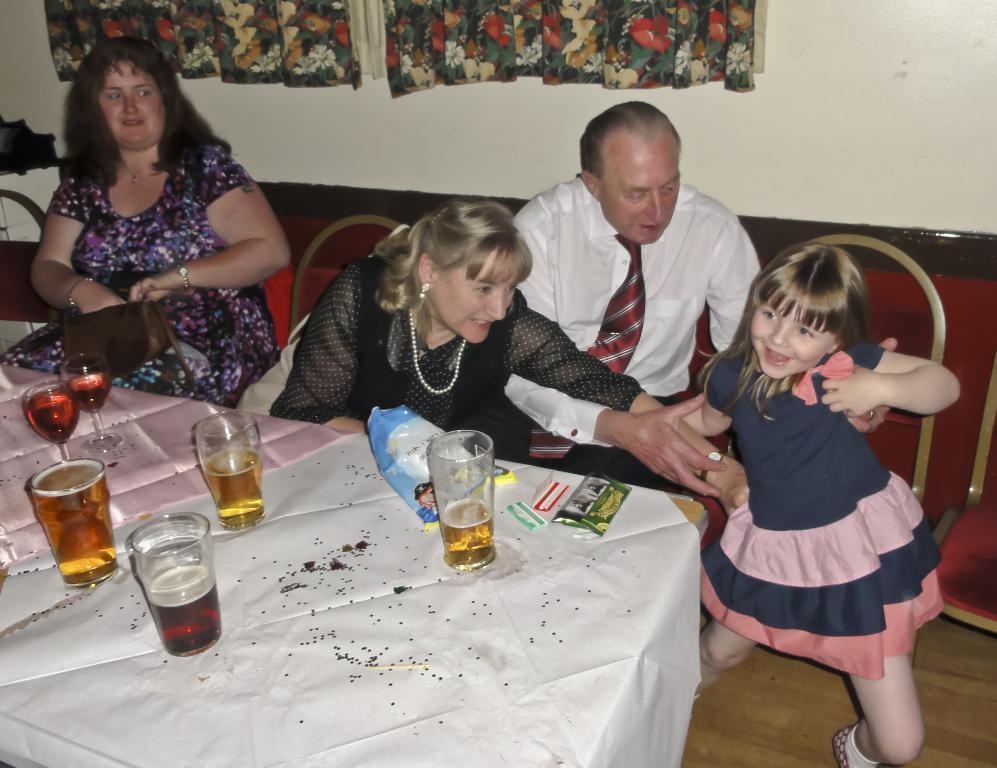Please provide a concise description of this image. In this image there are group of persons sitting on the chair. In the center a table is covered with white colour cloth. On the table there are glasses, packet, paper. In the background there is a wall and curtain. 